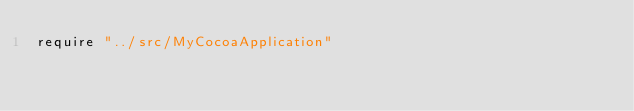Convert code to text. <code><loc_0><loc_0><loc_500><loc_500><_Crystal_>require "../src/MyCocoaApplication"
</code> 